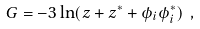<formula> <loc_0><loc_0><loc_500><loc_500>G = - 3 \ln ( z + z ^ { * } + \phi _ { i } \phi _ { i } ^ { * } ) \ ,</formula> 